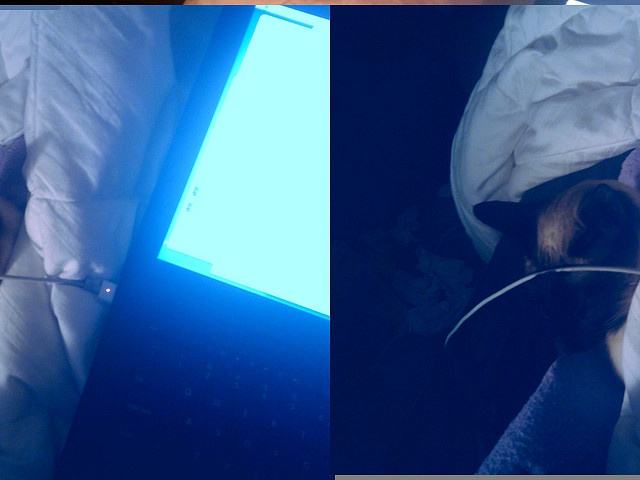Describe the objects in this image and their specific colors. I can see laptop in black, cyan, navy, blue, and lightblue tones, bed in black, blue, gray, and navy tones, and cat in black, navy, gray, and darkblue tones in this image. 